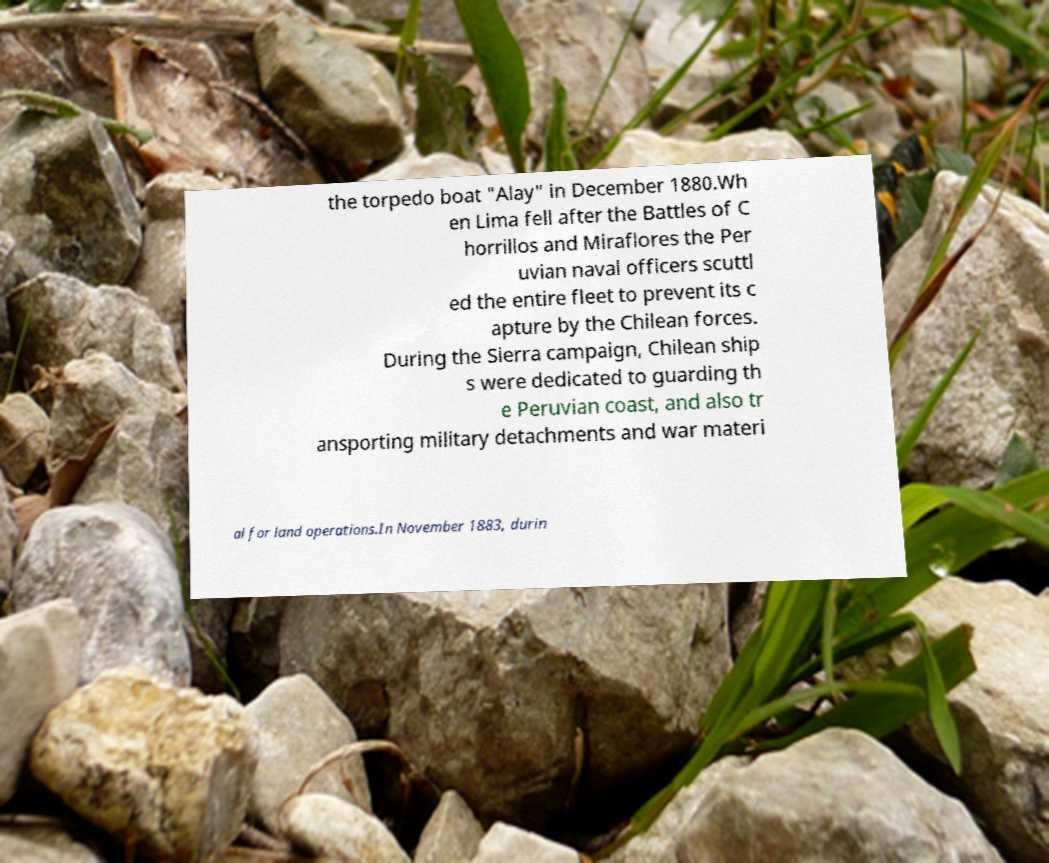Please read and relay the text visible in this image. What does it say? the torpedo boat "Alay" in December 1880.Wh en Lima fell after the Battles of C horrillos and Miraflores the Per uvian naval officers scuttl ed the entire fleet to prevent its c apture by the Chilean forces. During the Sierra campaign, Chilean ship s were dedicated to guarding th e Peruvian coast, and also tr ansporting military detachments and war materi al for land operations.In November 1883, durin 